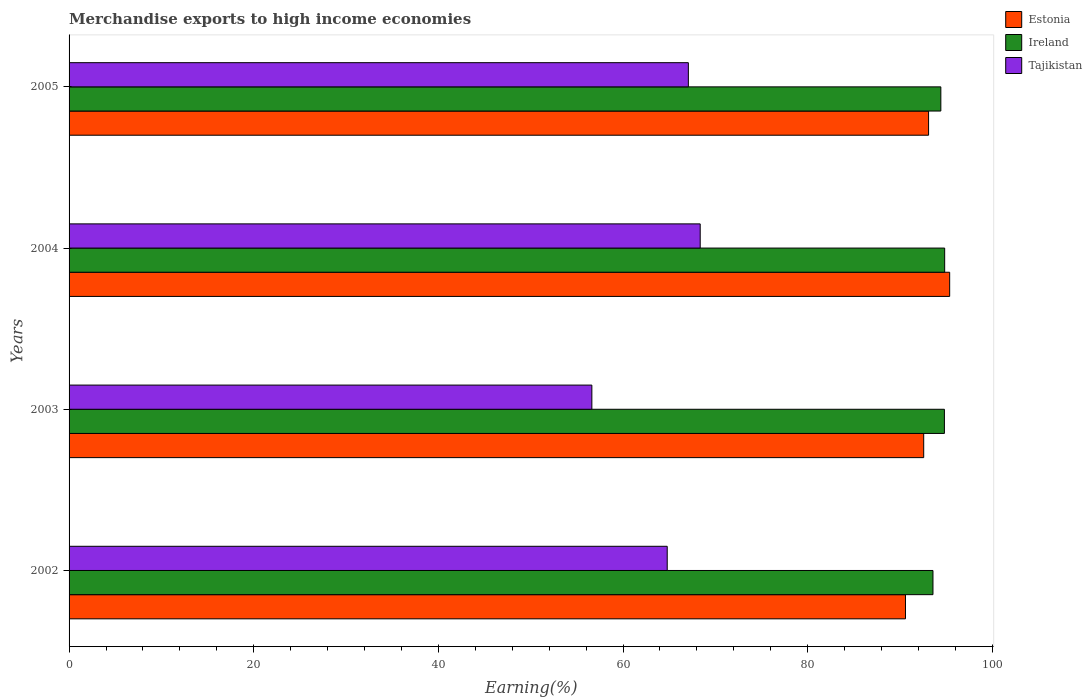How many groups of bars are there?
Offer a terse response. 4. Are the number of bars per tick equal to the number of legend labels?
Your answer should be compact. Yes. How many bars are there on the 4th tick from the top?
Offer a terse response. 3. What is the label of the 2nd group of bars from the top?
Provide a succinct answer. 2004. In how many cases, is the number of bars for a given year not equal to the number of legend labels?
Your response must be concise. 0. What is the percentage of amount earned from merchandise exports in Tajikistan in 2005?
Your answer should be very brief. 67.07. Across all years, what is the maximum percentage of amount earned from merchandise exports in Estonia?
Provide a succinct answer. 95.38. Across all years, what is the minimum percentage of amount earned from merchandise exports in Tajikistan?
Your answer should be compact. 56.62. In which year was the percentage of amount earned from merchandise exports in Ireland maximum?
Provide a succinct answer. 2004. In which year was the percentage of amount earned from merchandise exports in Ireland minimum?
Your response must be concise. 2002. What is the total percentage of amount earned from merchandise exports in Ireland in the graph?
Your answer should be compact. 377.63. What is the difference between the percentage of amount earned from merchandise exports in Estonia in 2003 and that in 2004?
Your answer should be very brief. -2.81. What is the difference between the percentage of amount earned from merchandise exports in Ireland in 2003 and the percentage of amount earned from merchandise exports in Estonia in 2002?
Keep it short and to the point. 4.21. What is the average percentage of amount earned from merchandise exports in Tajikistan per year?
Make the answer very short. 64.21. In the year 2002, what is the difference between the percentage of amount earned from merchandise exports in Estonia and percentage of amount earned from merchandise exports in Ireland?
Your answer should be compact. -2.98. In how many years, is the percentage of amount earned from merchandise exports in Estonia greater than 12 %?
Ensure brevity in your answer.  4. What is the ratio of the percentage of amount earned from merchandise exports in Ireland in 2002 to that in 2004?
Your answer should be very brief. 0.99. What is the difference between the highest and the second highest percentage of amount earned from merchandise exports in Estonia?
Your answer should be very brief. 2.28. What is the difference between the highest and the lowest percentage of amount earned from merchandise exports in Tajikistan?
Your response must be concise. 11.73. What does the 3rd bar from the top in 2004 represents?
Your answer should be very brief. Estonia. What does the 3rd bar from the bottom in 2005 represents?
Offer a very short reply. Tajikistan. Is it the case that in every year, the sum of the percentage of amount earned from merchandise exports in Estonia and percentage of amount earned from merchandise exports in Tajikistan is greater than the percentage of amount earned from merchandise exports in Ireland?
Provide a short and direct response. Yes. How many years are there in the graph?
Keep it short and to the point. 4. What is the difference between two consecutive major ticks on the X-axis?
Your answer should be very brief. 20. Are the values on the major ticks of X-axis written in scientific E-notation?
Make the answer very short. No. Does the graph contain any zero values?
Provide a short and direct response. No. Where does the legend appear in the graph?
Offer a terse response. Top right. How many legend labels are there?
Provide a short and direct response. 3. How are the legend labels stacked?
Give a very brief answer. Vertical. What is the title of the graph?
Provide a short and direct response. Merchandise exports to high income economies. Does "Slovak Republic" appear as one of the legend labels in the graph?
Provide a succinct answer. No. What is the label or title of the X-axis?
Give a very brief answer. Earning(%). What is the label or title of the Y-axis?
Your answer should be compact. Years. What is the Earning(%) in Estonia in 2002?
Make the answer very short. 90.59. What is the Earning(%) of Ireland in 2002?
Offer a very short reply. 93.57. What is the Earning(%) in Tajikistan in 2002?
Make the answer very short. 64.78. What is the Earning(%) in Estonia in 2003?
Your answer should be very brief. 92.56. What is the Earning(%) of Ireland in 2003?
Your response must be concise. 94.81. What is the Earning(%) of Tajikistan in 2003?
Your answer should be compact. 56.62. What is the Earning(%) in Estonia in 2004?
Provide a short and direct response. 95.38. What is the Earning(%) of Ireland in 2004?
Provide a succinct answer. 94.84. What is the Earning(%) in Tajikistan in 2004?
Keep it short and to the point. 68.36. What is the Earning(%) of Estonia in 2005?
Offer a very short reply. 93.09. What is the Earning(%) of Ireland in 2005?
Ensure brevity in your answer.  94.42. What is the Earning(%) in Tajikistan in 2005?
Keep it short and to the point. 67.07. Across all years, what is the maximum Earning(%) in Estonia?
Your answer should be very brief. 95.38. Across all years, what is the maximum Earning(%) in Ireland?
Your answer should be very brief. 94.84. Across all years, what is the maximum Earning(%) in Tajikistan?
Provide a succinct answer. 68.36. Across all years, what is the minimum Earning(%) in Estonia?
Make the answer very short. 90.59. Across all years, what is the minimum Earning(%) of Ireland?
Make the answer very short. 93.57. Across all years, what is the minimum Earning(%) in Tajikistan?
Offer a terse response. 56.62. What is the total Earning(%) of Estonia in the graph?
Provide a short and direct response. 371.62. What is the total Earning(%) of Ireland in the graph?
Provide a succinct answer. 377.63. What is the total Earning(%) of Tajikistan in the graph?
Offer a terse response. 256.84. What is the difference between the Earning(%) of Estonia in 2002 and that in 2003?
Provide a succinct answer. -1.97. What is the difference between the Earning(%) in Ireland in 2002 and that in 2003?
Your response must be concise. -1.24. What is the difference between the Earning(%) in Tajikistan in 2002 and that in 2003?
Give a very brief answer. 8.16. What is the difference between the Earning(%) in Estonia in 2002 and that in 2004?
Offer a terse response. -4.79. What is the difference between the Earning(%) of Ireland in 2002 and that in 2004?
Keep it short and to the point. -1.27. What is the difference between the Earning(%) of Tajikistan in 2002 and that in 2004?
Make the answer very short. -3.57. What is the difference between the Earning(%) of Estonia in 2002 and that in 2005?
Ensure brevity in your answer.  -2.5. What is the difference between the Earning(%) of Ireland in 2002 and that in 2005?
Offer a very short reply. -0.85. What is the difference between the Earning(%) in Tajikistan in 2002 and that in 2005?
Your answer should be compact. -2.29. What is the difference between the Earning(%) of Estonia in 2003 and that in 2004?
Give a very brief answer. -2.81. What is the difference between the Earning(%) of Ireland in 2003 and that in 2004?
Offer a very short reply. -0.03. What is the difference between the Earning(%) of Tajikistan in 2003 and that in 2004?
Offer a very short reply. -11.73. What is the difference between the Earning(%) in Estonia in 2003 and that in 2005?
Keep it short and to the point. -0.53. What is the difference between the Earning(%) in Ireland in 2003 and that in 2005?
Ensure brevity in your answer.  0.39. What is the difference between the Earning(%) in Tajikistan in 2003 and that in 2005?
Your answer should be very brief. -10.45. What is the difference between the Earning(%) in Estonia in 2004 and that in 2005?
Make the answer very short. 2.28. What is the difference between the Earning(%) of Ireland in 2004 and that in 2005?
Provide a short and direct response. 0.42. What is the difference between the Earning(%) in Tajikistan in 2004 and that in 2005?
Ensure brevity in your answer.  1.28. What is the difference between the Earning(%) of Estonia in 2002 and the Earning(%) of Ireland in 2003?
Give a very brief answer. -4.21. What is the difference between the Earning(%) in Estonia in 2002 and the Earning(%) in Tajikistan in 2003?
Make the answer very short. 33.97. What is the difference between the Earning(%) of Ireland in 2002 and the Earning(%) of Tajikistan in 2003?
Your response must be concise. 36.94. What is the difference between the Earning(%) in Estonia in 2002 and the Earning(%) in Ireland in 2004?
Your response must be concise. -4.25. What is the difference between the Earning(%) in Estonia in 2002 and the Earning(%) in Tajikistan in 2004?
Ensure brevity in your answer.  22.23. What is the difference between the Earning(%) in Ireland in 2002 and the Earning(%) in Tajikistan in 2004?
Ensure brevity in your answer.  25.21. What is the difference between the Earning(%) of Estonia in 2002 and the Earning(%) of Ireland in 2005?
Keep it short and to the point. -3.83. What is the difference between the Earning(%) of Estonia in 2002 and the Earning(%) of Tajikistan in 2005?
Your answer should be very brief. 23.52. What is the difference between the Earning(%) of Ireland in 2002 and the Earning(%) of Tajikistan in 2005?
Your answer should be very brief. 26.49. What is the difference between the Earning(%) of Estonia in 2003 and the Earning(%) of Ireland in 2004?
Provide a succinct answer. -2.27. What is the difference between the Earning(%) of Estonia in 2003 and the Earning(%) of Tajikistan in 2004?
Give a very brief answer. 24.21. What is the difference between the Earning(%) in Ireland in 2003 and the Earning(%) in Tajikistan in 2004?
Ensure brevity in your answer.  26.45. What is the difference between the Earning(%) in Estonia in 2003 and the Earning(%) in Ireland in 2005?
Provide a succinct answer. -1.86. What is the difference between the Earning(%) in Estonia in 2003 and the Earning(%) in Tajikistan in 2005?
Your response must be concise. 25.49. What is the difference between the Earning(%) in Ireland in 2003 and the Earning(%) in Tajikistan in 2005?
Your answer should be very brief. 27.73. What is the difference between the Earning(%) in Estonia in 2004 and the Earning(%) in Ireland in 2005?
Your response must be concise. 0.96. What is the difference between the Earning(%) of Estonia in 2004 and the Earning(%) of Tajikistan in 2005?
Offer a terse response. 28.3. What is the difference between the Earning(%) of Ireland in 2004 and the Earning(%) of Tajikistan in 2005?
Offer a very short reply. 27.76. What is the average Earning(%) in Estonia per year?
Provide a short and direct response. 92.91. What is the average Earning(%) of Ireland per year?
Offer a terse response. 94.41. What is the average Earning(%) of Tajikistan per year?
Your response must be concise. 64.21. In the year 2002, what is the difference between the Earning(%) in Estonia and Earning(%) in Ireland?
Offer a very short reply. -2.98. In the year 2002, what is the difference between the Earning(%) in Estonia and Earning(%) in Tajikistan?
Ensure brevity in your answer.  25.81. In the year 2002, what is the difference between the Earning(%) in Ireland and Earning(%) in Tajikistan?
Give a very brief answer. 28.78. In the year 2003, what is the difference between the Earning(%) of Estonia and Earning(%) of Ireland?
Your answer should be very brief. -2.24. In the year 2003, what is the difference between the Earning(%) of Estonia and Earning(%) of Tajikistan?
Keep it short and to the point. 35.94. In the year 2003, what is the difference between the Earning(%) of Ireland and Earning(%) of Tajikistan?
Provide a short and direct response. 38.18. In the year 2004, what is the difference between the Earning(%) of Estonia and Earning(%) of Ireland?
Provide a succinct answer. 0.54. In the year 2004, what is the difference between the Earning(%) of Estonia and Earning(%) of Tajikistan?
Ensure brevity in your answer.  27.02. In the year 2004, what is the difference between the Earning(%) in Ireland and Earning(%) in Tajikistan?
Give a very brief answer. 26.48. In the year 2005, what is the difference between the Earning(%) of Estonia and Earning(%) of Ireland?
Keep it short and to the point. -1.33. In the year 2005, what is the difference between the Earning(%) in Estonia and Earning(%) in Tajikistan?
Provide a short and direct response. 26.02. In the year 2005, what is the difference between the Earning(%) in Ireland and Earning(%) in Tajikistan?
Make the answer very short. 27.35. What is the ratio of the Earning(%) of Estonia in 2002 to that in 2003?
Keep it short and to the point. 0.98. What is the ratio of the Earning(%) of Ireland in 2002 to that in 2003?
Ensure brevity in your answer.  0.99. What is the ratio of the Earning(%) in Tajikistan in 2002 to that in 2003?
Your answer should be compact. 1.14. What is the ratio of the Earning(%) of Estonia in 2002 to that in 2004?
Offer a terse response. 0.95. What is the ratio of the Earning(%) in Ireland in 2002 to that in 2004?
Ensure brevity in your answer.  0.99. What is the ratio of the Earning(%) of Tajikistan in 2002 to that in 2004?
Offer a very short reply. 0.95. What is the ratio of the Earning(%) in Estonia in 2002 to that in 2005?
Keep it short and to the point. 0.97. What is the ratio of the Earning(%) of Tajikistan in 2002 to that in 2005?
Give a very brief answer. 0.97. What is the ratio of the Earning(%) in Estonia in 2003 to that in 2004?
Your answer should be compact. 0.97. What is the ratio of the Earning(%) in Tajikistan in 2003 to that in 2004?
Keep it short and to the point. 0.83. What is the ratio of the Earning(%) of Tajikistan in 2003 to that in 2005?
Your answer should be very brief. 0.84. What is the ratio of the Earning(%) of Estonia in 2004 to that in 2005?
Keep it short and to the point. 1.02. What is the ratio of the Earning(%) of Ireland in 2004 to that in 2005?
Make the answer very short. 1. What is the ratio of the Earning(%) of Tajikistan in 2004 to that in 2005?
Give a very brief answer. 1.02. What is the difference between the highest and the second highest Earning(%) in Estonia?
Offer a terse response. 2.28. What is the difference between the highest and the second highest Earning(%) of Ireland?
Provide a succinct answer. 0.03. What is the difference between the highest and the second highest Earning(%) of Tajikistan?
Give a very brief answer. 1.28. What is the difference between the highest and the lowest Earning(%) of Estonia?
Offer a very short reply. 4.79. What is the difference between the highest and the lowest Earning(%) of Ireland?
Make the answer very short. 1.27. What is the difference between the highest and the lowest Earning(%) of Tajikistan?
Offer a very short reply. 11.73. 